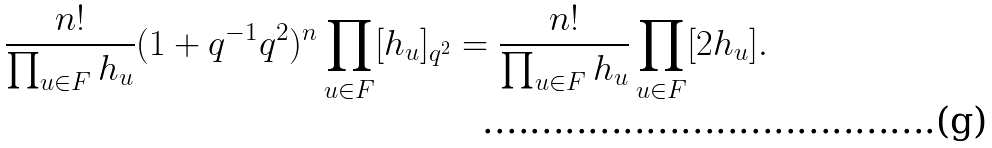Convert formula to latex. <formula><loc_0><loc_0><loc_500><loc_500>\frac { n ! } { \prod _ { u \in F } h _ { u } } ( 1 + q ^ { - 1 } q ^ { 2 } ) ^ { n } \prod _ { u \in F } [ h _ { u } ] _ { q ^ { 2 } } = \frac { n ! } { \prod _ { u \in F } h _ { u } } \prod _ { u \in F } [ 2 h _ { u } ] .</formula> 